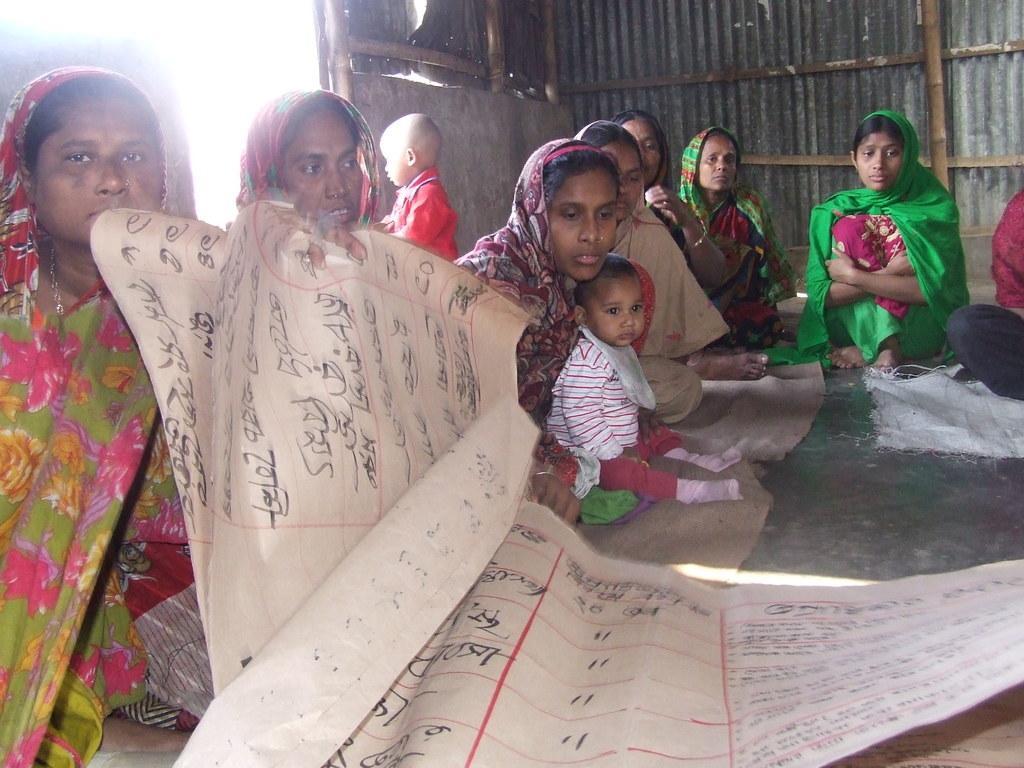Describe this image in one or two sentences. In the image there are some people sitting on the floor and on the left side a person is holding a chart and behind the people there is a wall made up of aluminium and it is supported with wooden sticks. 